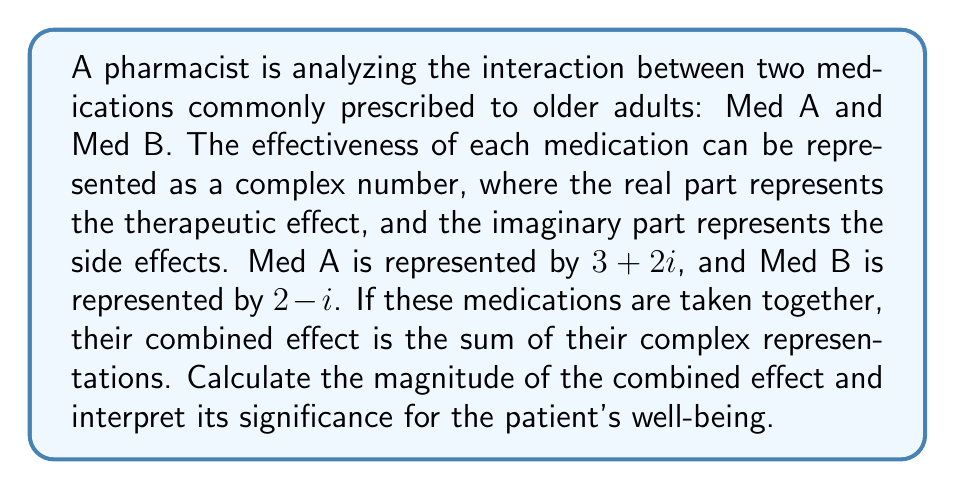Help me with this question. To solve this problem, we'll follow these steps:

1) First, we need to add the complex numbers representing Med A and Med B:

   Med A: $3 + 2i$
   Med B: $2 - i$
   
   Combined effect = $(3 + 2i) + (2 - i) = 5 + i$

2) Now, we need to calculate the magnitude of this combined effect. The magnitude of a complex number $a + bi$ is given by the formula:

   $\sqrt{a^2 + b^2}$

3) In our case, $a = 5$ and $b = 1$. Let's substitute these values:

   Magnitude = $\sqrt{5^2 + 1^2} = \sqrt{25 + 1} = \sqrt{26}$

4) To interpret this result:
   - The magnitude represents the overall strength of the combined medications.
   - A larger magnitude indicates a stronger overall effect, which could mean more potent therapeutic effects but also potentially stronger side effects.
   - The original magnitudes were:
     Med A: $\sqrt{3^2 + 2^2} = \sqrt{13} \approx 3.61$
     Med B: $\sqrt{2^2 + (-1)^2} = \sqrt{5} \approx 2.24$
   - The combined magnitude ($\sqrt{26} \approx 5.10$) is greater than either medication alone, suggesting a potentially more powerful overall effect.

5) For the patient's well-being, this means:
   - The combined medications may have a stronger therapeutic effect.
   - However, there's also a risk of increased side effects.
   - Careful monitoring by the pharmacist and healthcare team is crucial to ensure the benefits outweigh the risks for the older adult patient.
Answer: $\sqrt{26}$ 